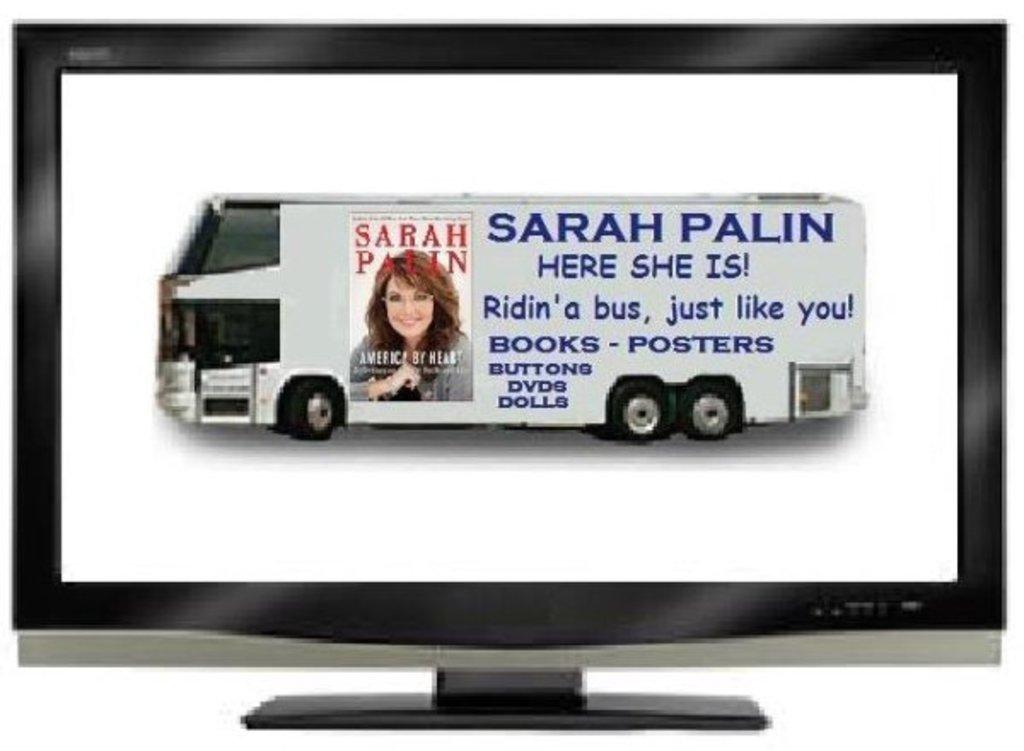Who is on this bus?
Your answer should be compact. Sarah palin. What does the bus sell?
Your answer should be very brief. Books, posters, buttons, dvds, dolls. 